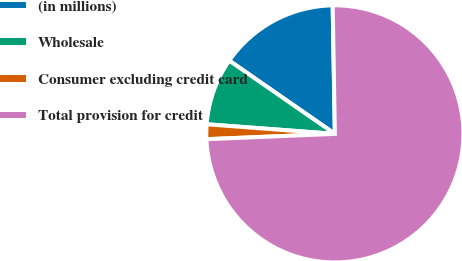Convert chart to OTSL. <chart><loc_0><loc_0><loc_500><loc_500><pie_chart><fcel>(in millions)<fcel>Wholesale<fcel>Consumer excluding credit card<fcel>Total provision for credit<nl><fcel>15.08%<fcel>8.46%<fcel>1.85%<fcel>74.61%<nl></chart> 